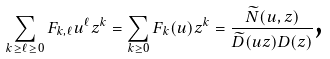Convert formula to latex. <formula><loc_0><loc_0><loc_500><loc_500>\sum _ { k \geq \ell \geq 0 } F _ { k , \ell } u ^ { \ell } z ^ { k } = \sum _ { k \geq 0 } F _ { k } ( u ) z ^ { k } = \frac { \widetilde { N } ( u , z ) } { \widetilde { D } ( u z ) D ( z ) } \text  ,</formula> 